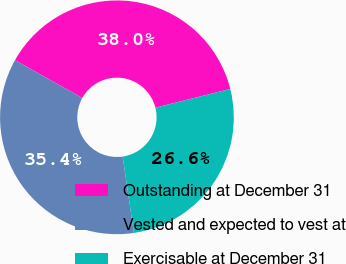Convert chart to OTSL. <chart><loc_0><loc_0><loc_500><loc_500><pie_chart><fcel>Outstanding at December 31<fcel>Vested and expected to vest at<fcel>Exercisable at December 31<nl><fcel>37.97%<fcel>35.44%<fcel>26.58%<nl></chart> 